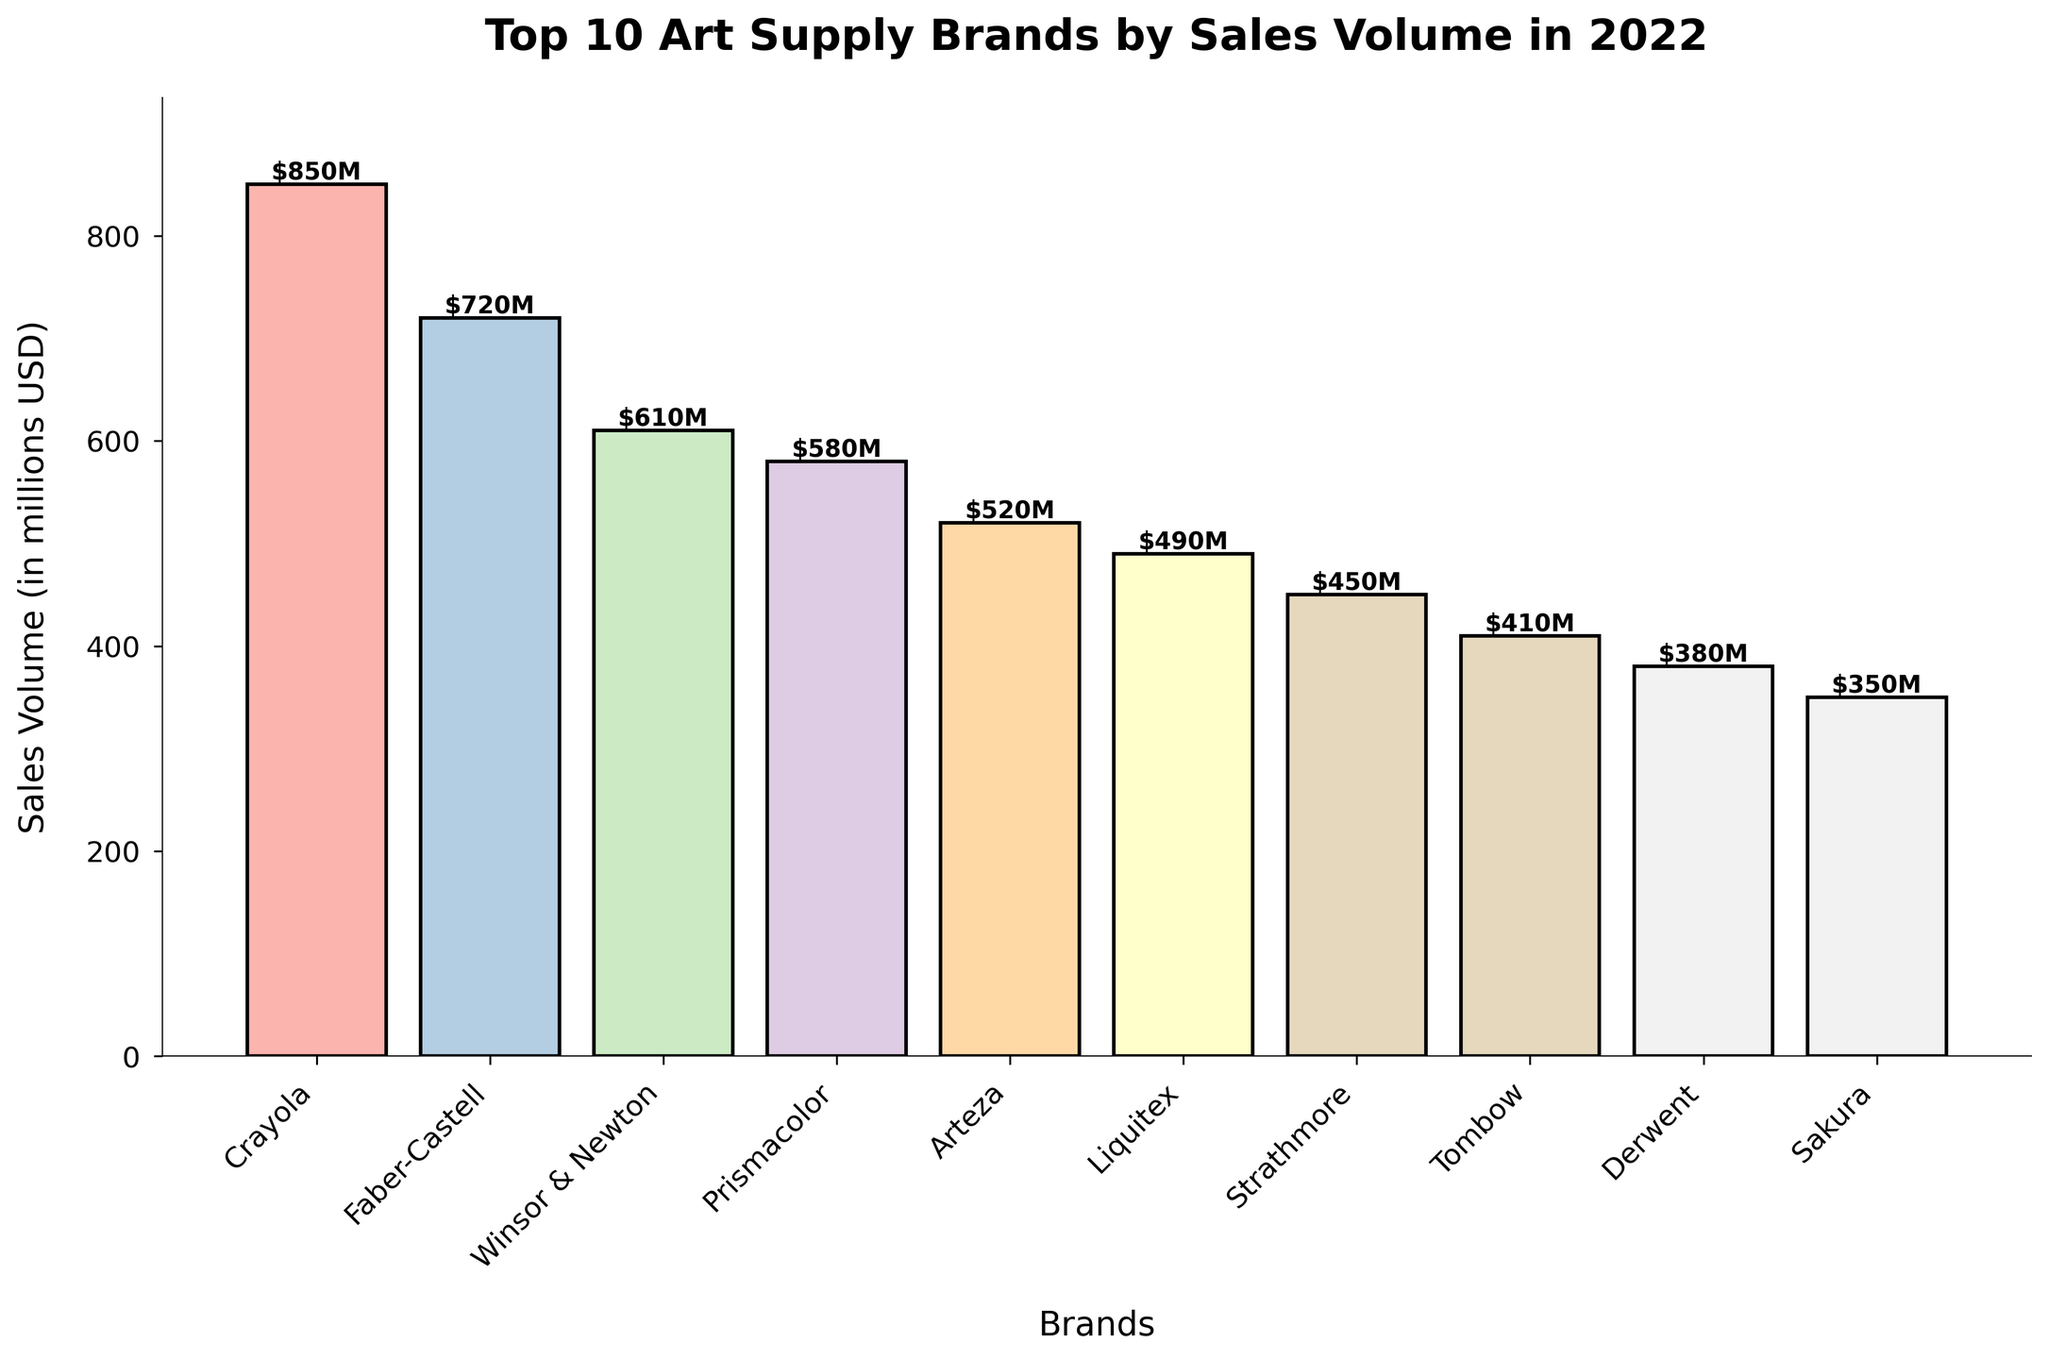What is the total sales volume of the top 3 brands combined? The top 3 brands are Crayola, Faber-Castell, and Winsor & Newton. Their sales volumes are 850, 720, and 610 million USD respectively. The total sales volume is 850 + 720 + 610 = 2,180 million USD.
Answer: 2,180 million USD Which brand has the lowest sales volume, and what is that value? The brand with the lowest sales volume is Sakura, which has a sales volume of 350 million USD according to the bar height.
Answer: Sakura, 350 million USD How much more did Crayola sell compared to Tombow? Crayola's sales volume is 850 million USD, and Tombow's is 410 million USD. The difference in sales volume is 850 - 410 = 440 million USD.
Answer: 440 million USD Which brands have sales volumes between 400 million USD and 500 million USD? Brands in this range are Liquitex and Tombow, which have sales volumes of 490 and 410 million USD respectively, as seen from their bar heights.
Answer: Liquitex and Tombow What is the average sales volume of all the brands? Sum all sales volumes: 850 + 720 + 610 + 580 + 520 + 490 + 450 + 410 + 380 + 350 = 4,860 million USD. Since there are 10 brands, the average is 4,860 / 10 = 486 million USD.
Answer: 486 million USD Which brand has the second-highest sales volume, and what is its value? The second-highest sales volume is by Faber-Castell, which has a sales volume of 720 million USD according to the bar height.
Answer: Faber-Castell, 720 million USD By how much does Arteza's sales volume exceed Sakura's? Arteza's sales volume is 520 million USD, and Sakura's sales volume is 350 million USD. The difference is 520 - 350 = 170 million USD.
Answer: 170 million USD How many brands have sales volumes greater than 500 million USD? The brands with sales volumes over 500 million USD are Crayola, Faber-Castell, Winsor & Newton, Prismacolor, and Arteza. This makes a total of 5 brands.
Answer: 5 brands Which brand has a higher sales volume, Strathmore or Derwent, and by how much? Strathmore has a sales volume of 450 million USD, and Derwent has 380 million USD. The difference is 450 - 380 = 70 million USD.
Answer: Strathmore, 70 million USD What is the combined sales volume of the brands with the lowest three sales volumes? The brands with the lowest three sales volumes are Sakura, Derwent, and Tombow, with sales volumes of 350, 380, and 410 million USD respectively. The combined sales volume is 350 + 380 + 410 = 1,140 million USD.
Answer: 1,140 million USD 